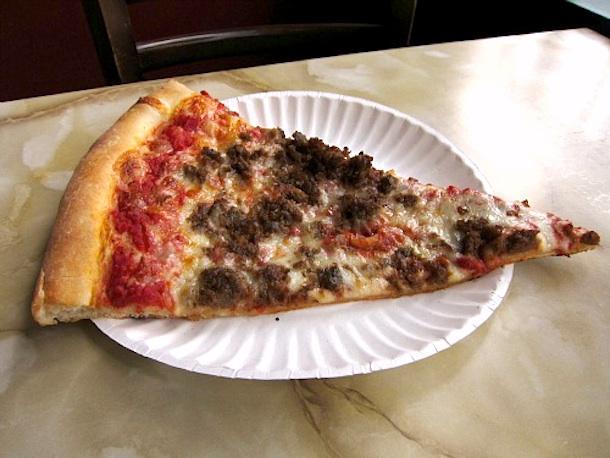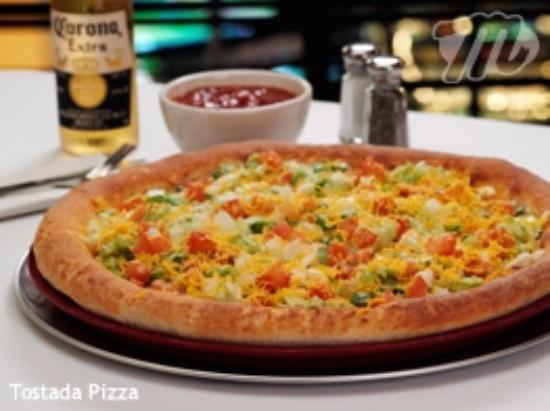The first image is the image on the left, the second image is the image on the right. For the images shown, is this caption "There are two pizzas in the right image." true? Answer yes or no. No. The first image is the image on the left, the second image is the image on the right. Considering the images on both sides, is "All pizzas are round pizzas." valid? Answer yes or no. No. 